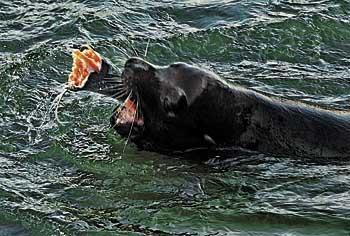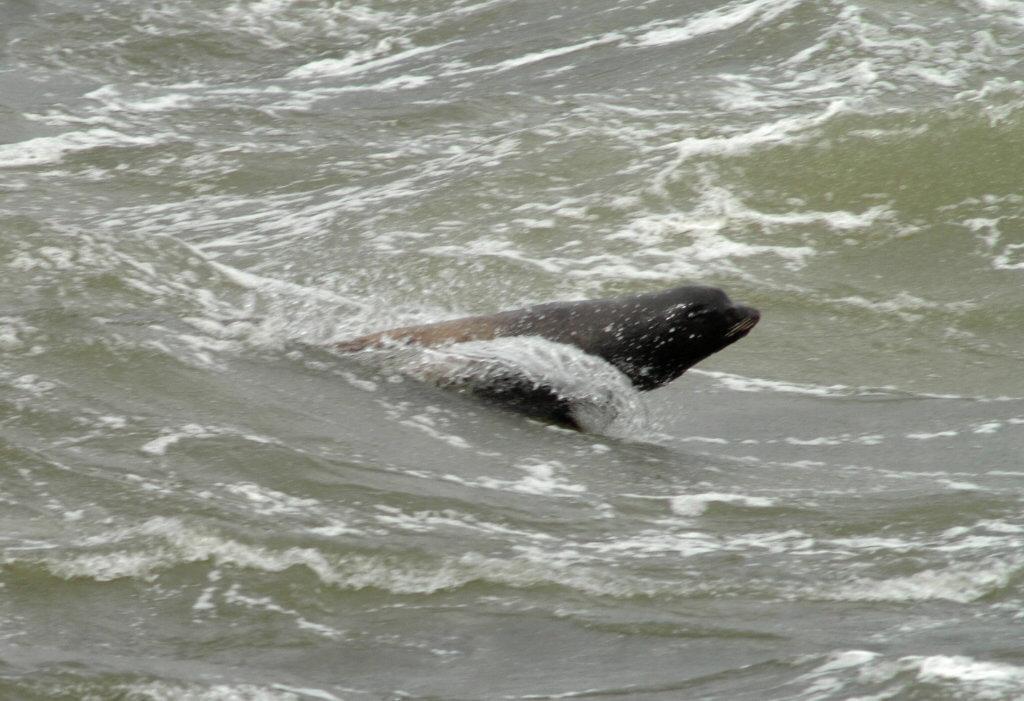The first image is the image on the left, the second image is the image on the right. For the images displayed, is the sentence "Each image shows one dark seal with its head showing above water, and in at least one image, the seal is chewing on torn orange-fleshed fish." factually correct? Answer yes or no. Yes. 